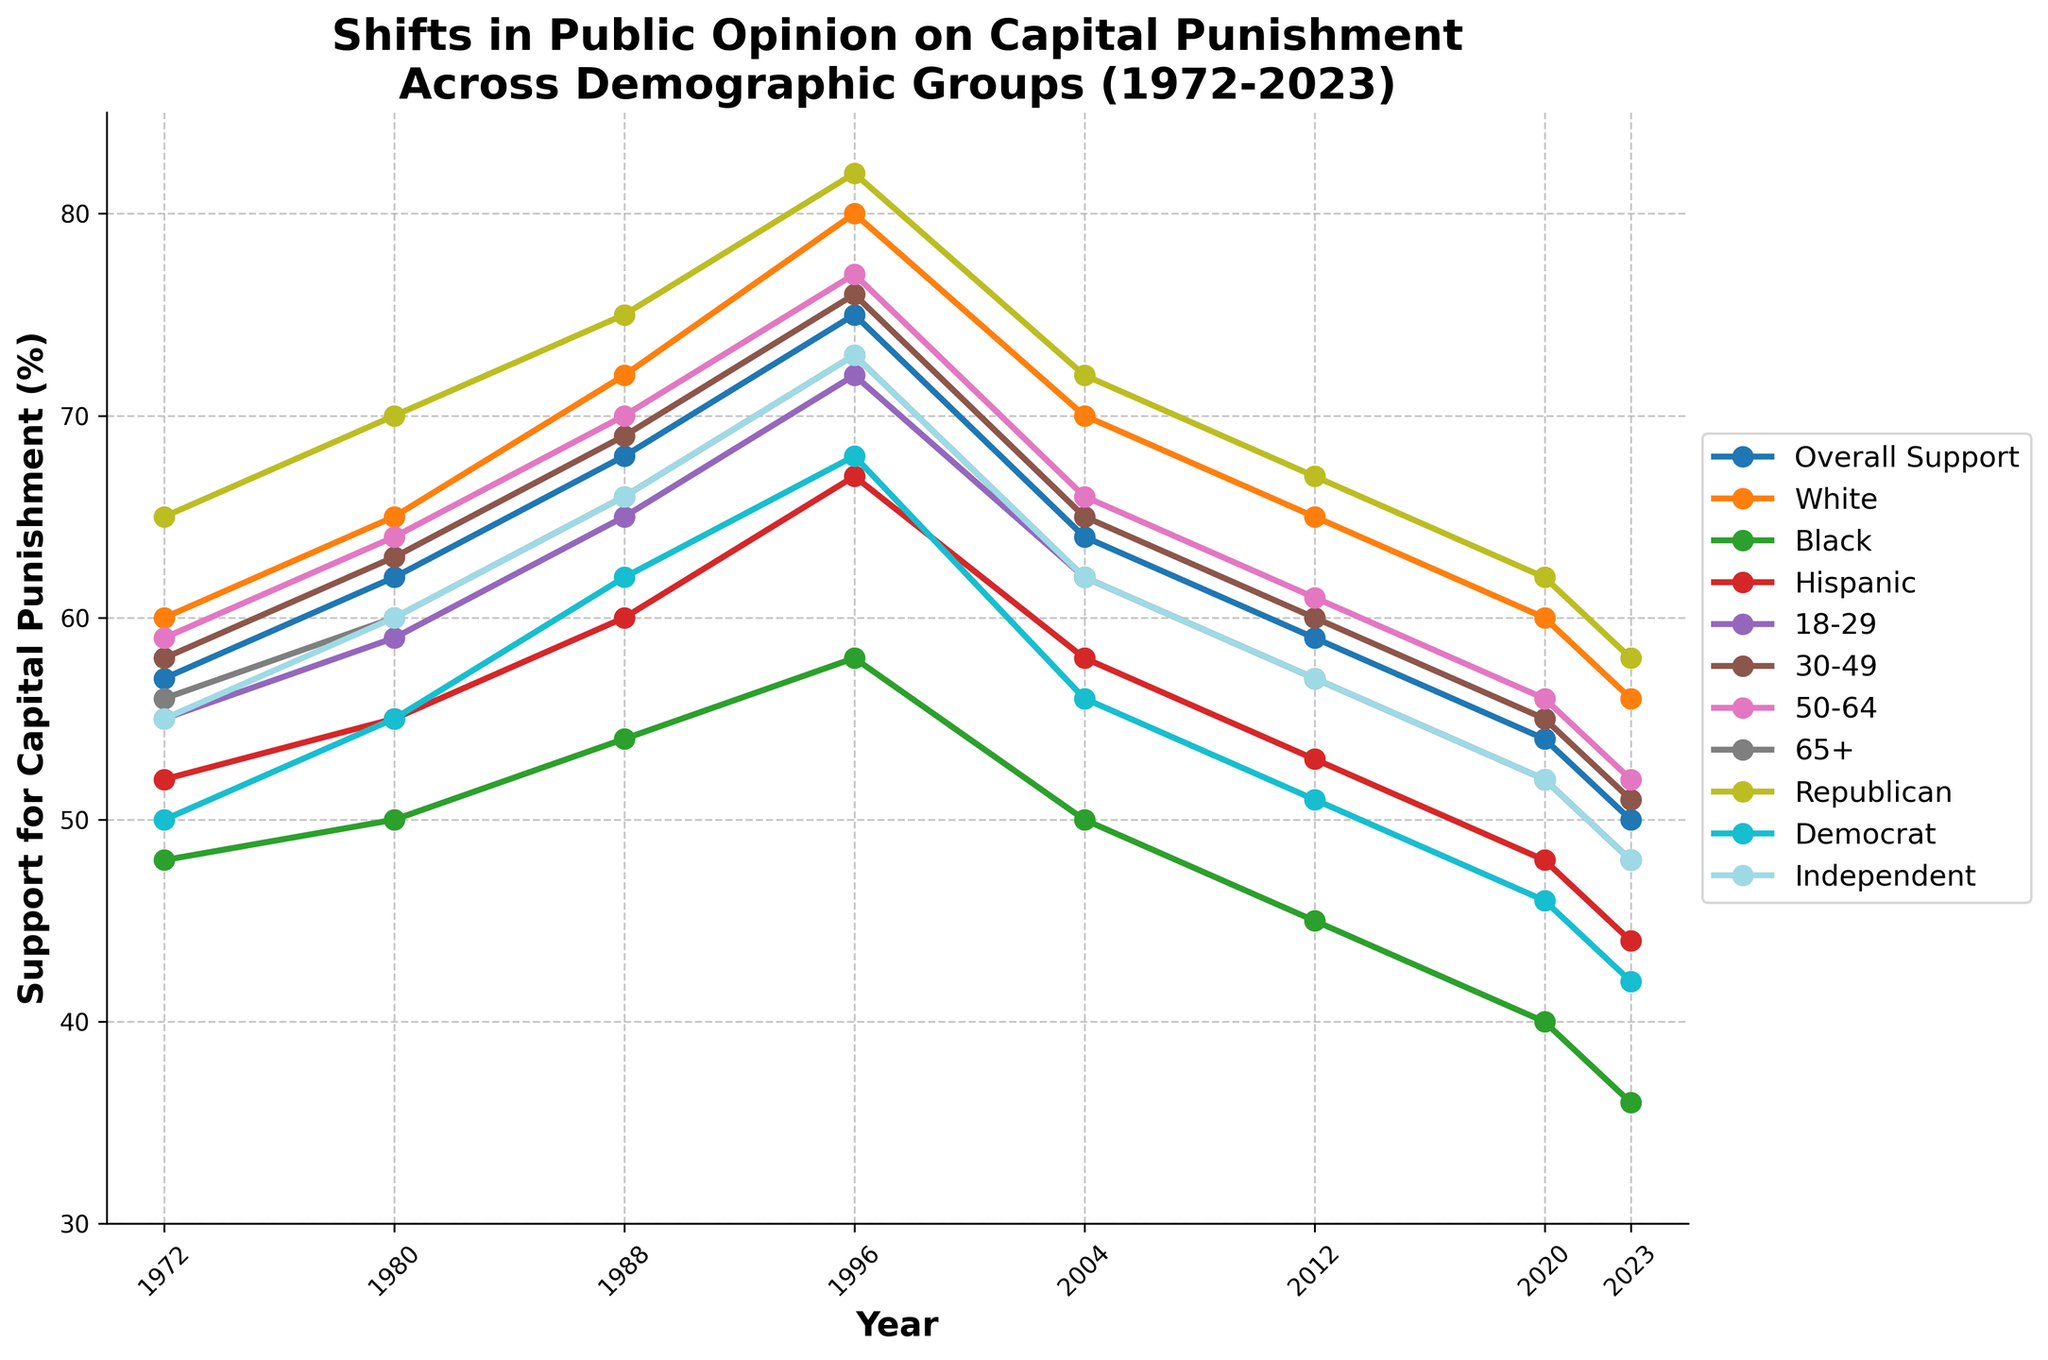Which demographic group had the highest overall support for capital punishment in 1996? By looking at the year 1996 on the x-axis and tracing it upwards to see the highest y-value, we can identify the demographic group. The highest value is 82% for the Republican group.
Answer: Republican How did the overall support for capital punishment change from 1972 to 2023? To determine the change, we look at the figures for 1972 and 2023. In 1972, the support was 57%, and it decreased to 50% in 2023. The change is 57% - 50% = 7%.
Answer: Decreased by 7% In which year did the support for capital punishment among Democrats fall below 50%? We need to identify the year when the Republican trend line falls below the 50% support level. It happened in 2020 when support was 46%.
Answer: 2020 Which group had the most significant decline in support from 1996 to 2023? We need to compare the support percentages for each group in 1996 and 2023 and calculate the difference. The Black demographic decreased from 58% in 1996 to 36% in 2023. The decline is 58% - 36% = 22%. This is the largest decline among the groups.
Answer: Black Is there a demographic where support consistently increased over the years? By analyzing each demographic trend line from 1972 to 2023, we can see that none of the groups have a consistently increasing trend; they all either decrease or have fluctuations.
Answer: No How does the support for capital punishment among Independents compare between 2012 and 2023? We compare the percentage values for Independents in 2012 and 2023. In 2012, the support was 57%, and in 2023, it was 48%. Thus, it decreased by 57% - 48% = 9%.
Answer: Decreased by 9% Which age group had the highest support for capital punishment in 1988? Looking at the year 1988 and comparing all age groups, the 50-64 age group had the highest support at 70%.
Answer: 50-64 How much did support for capital punishment among Republicans change from 1972 to 2023? Comparing the percentage values for Republicans in 1972 and 2023, we see a change from 65% to 58%. The change is 65% - 58% = 7%.
Answer: Decreased by 7% Which demographic group has shown the most stable support for capital punishment over the years? By visually inspecting the trend lines, the 50-64 age group appears to have the most stable line with relatively smaller fluctuations compared to other groups.
Answer: 50-64 